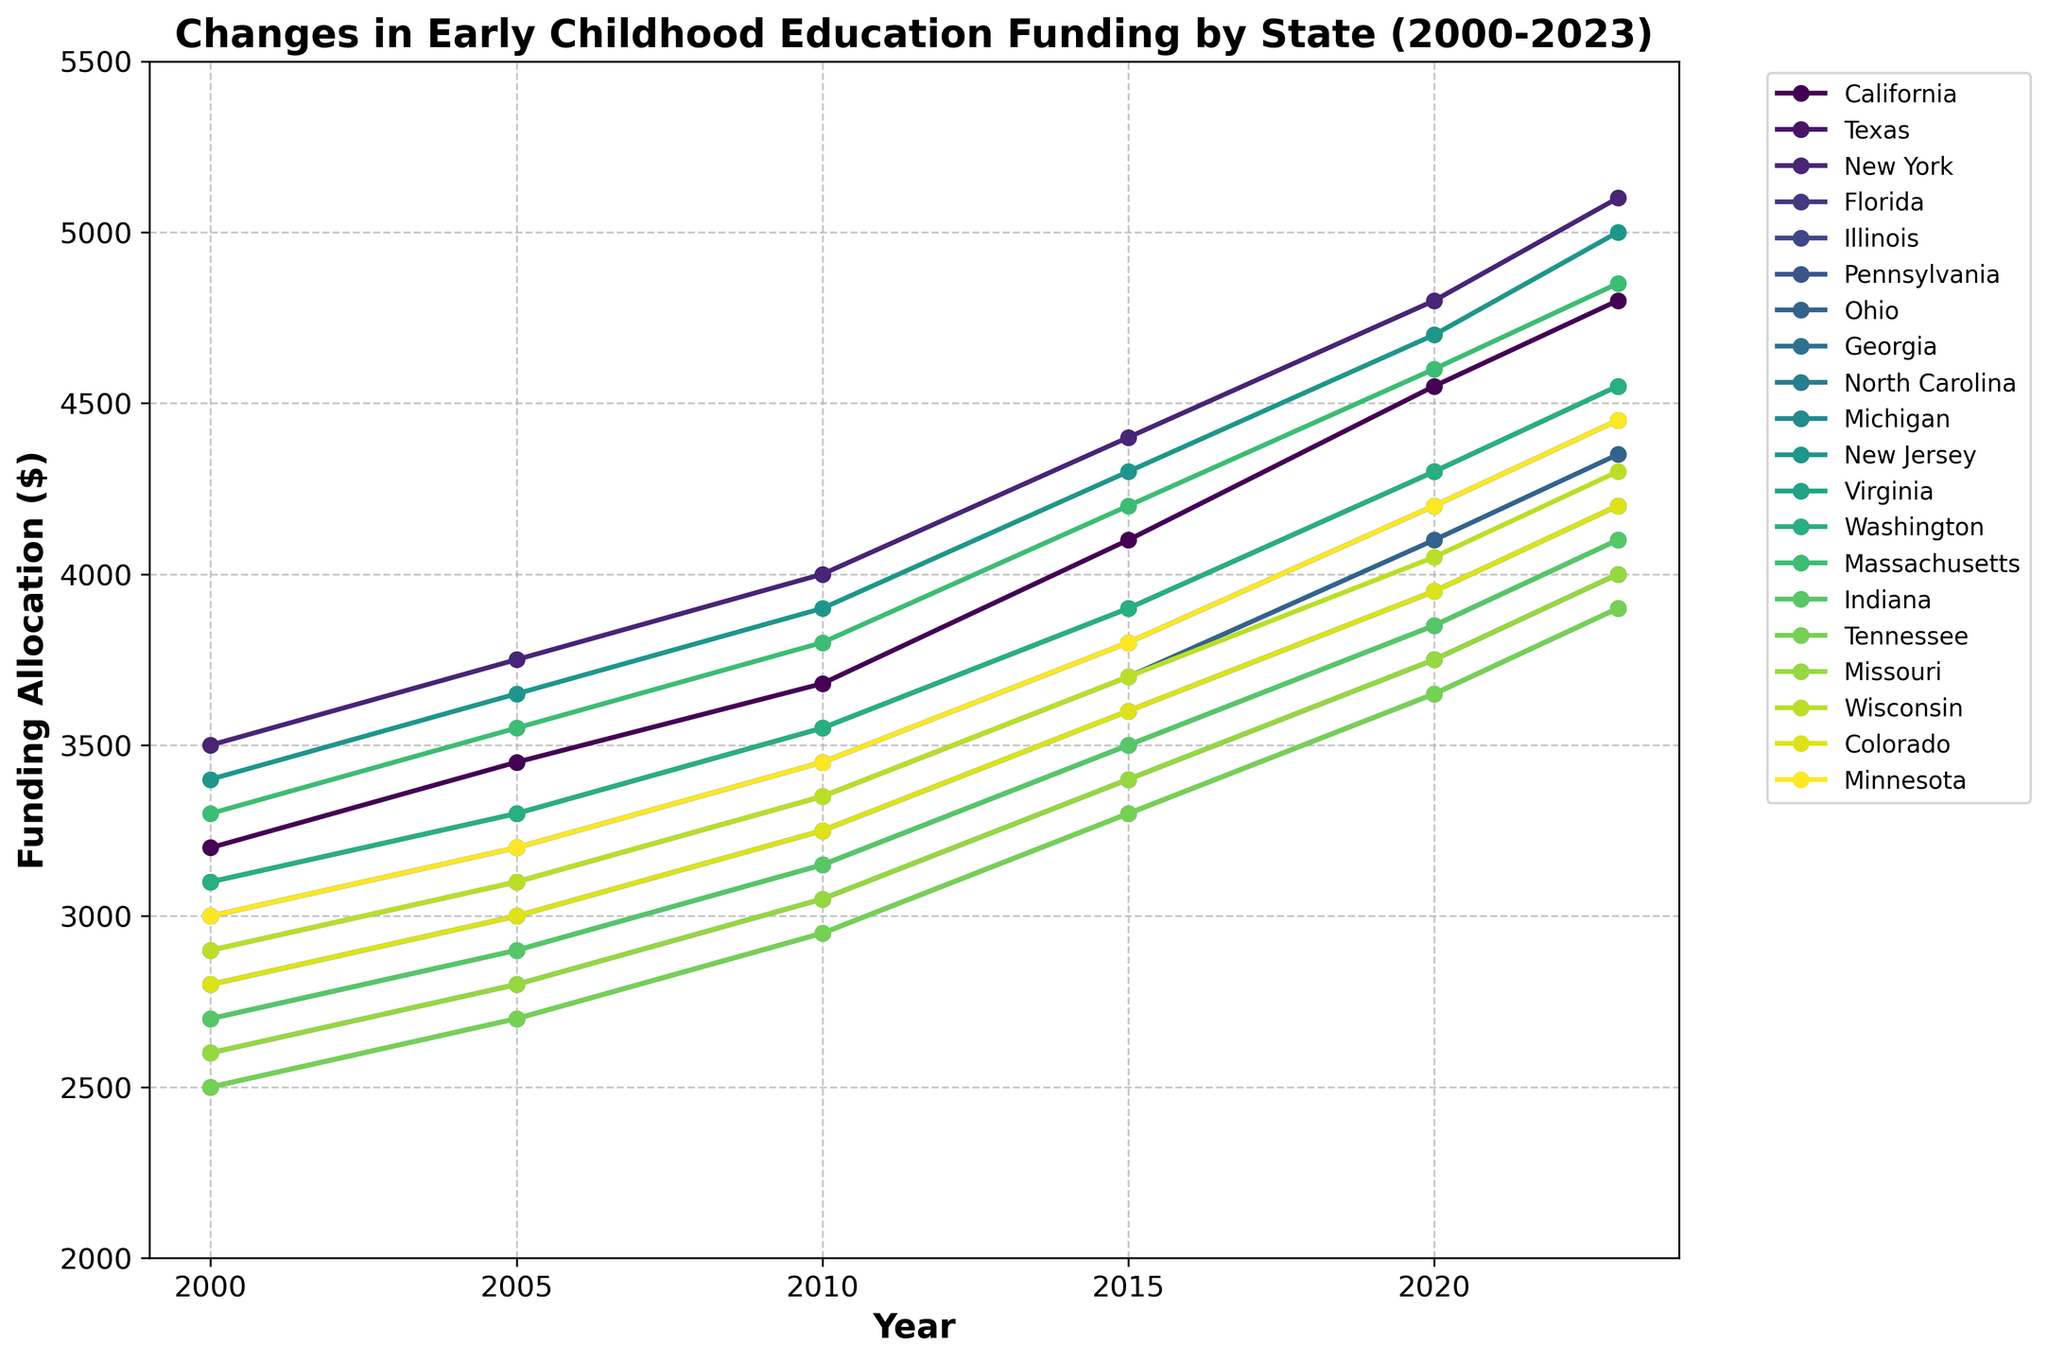What was the funding allocation for New York in 2015? Find the point on the New York line corresponding to the year 2015.
Answer: 4400 Which state had the highest funding allocation in 2023? Observe the endpoints of each line at the year 2023 and identify the highest. New York's endpoint is the highest.
Answer: New York What is the difference in funding allocation between California and Texas in 2023? Identify the endpoint values for California and Texas in 2023, then subtract the Texas value from the California value (4800 - 4200 = 600).
Answer: 600 How did the funding allocation for Florida change from 2000 to 2023? Locate the funding allocation for Florida in 2000 and 2023 from the graph, then calculate the difference (4000 - 2600 = 1400).
Answer: 1400 Which state shows the most consistent increase in funding allocation over the years? Observe the graphs and identify the state with the most uniform slope across all years.
Answer: California Between 2000 and 2020, which state had a larger increase in funding allocation, Ohio or Wisconsin? Calculate the increase for both states from 2000 to 2020 and compare. Ohio: 4100 - 2900 = 1200, Wisconsin: 4050 - 2900 = 1150, so Ohio's increase is larger.
Answer: Ohio How many states had a funding allocation of at least $4500 in 2020? Count the number of states where the funding allocation is at least $4500 in 2020.
Answer: Four (California, New York, New Jersey, Massachusetts) Which two states had the closest funding allocation values in 2023? Compare the endpoint values for all states in 2023 and find the two closest values.
Answer: Ohio and Michigan (both at 4450) In which year did Pennsylvania's funding allocation cross the $4000 mark? Analyze the Pennsylvania line to find the year it first surpasses $4000.
Answer: 2020 What is the average funding allocation for Virginia from 2000 to 2023? Sum Virginia's allocation for all the years and divide by the number of years: (2800 + 3000 + 3250 + 3600 + 3950 + 4200)/6 ≈ 3466.67
Answer: 3466.67 